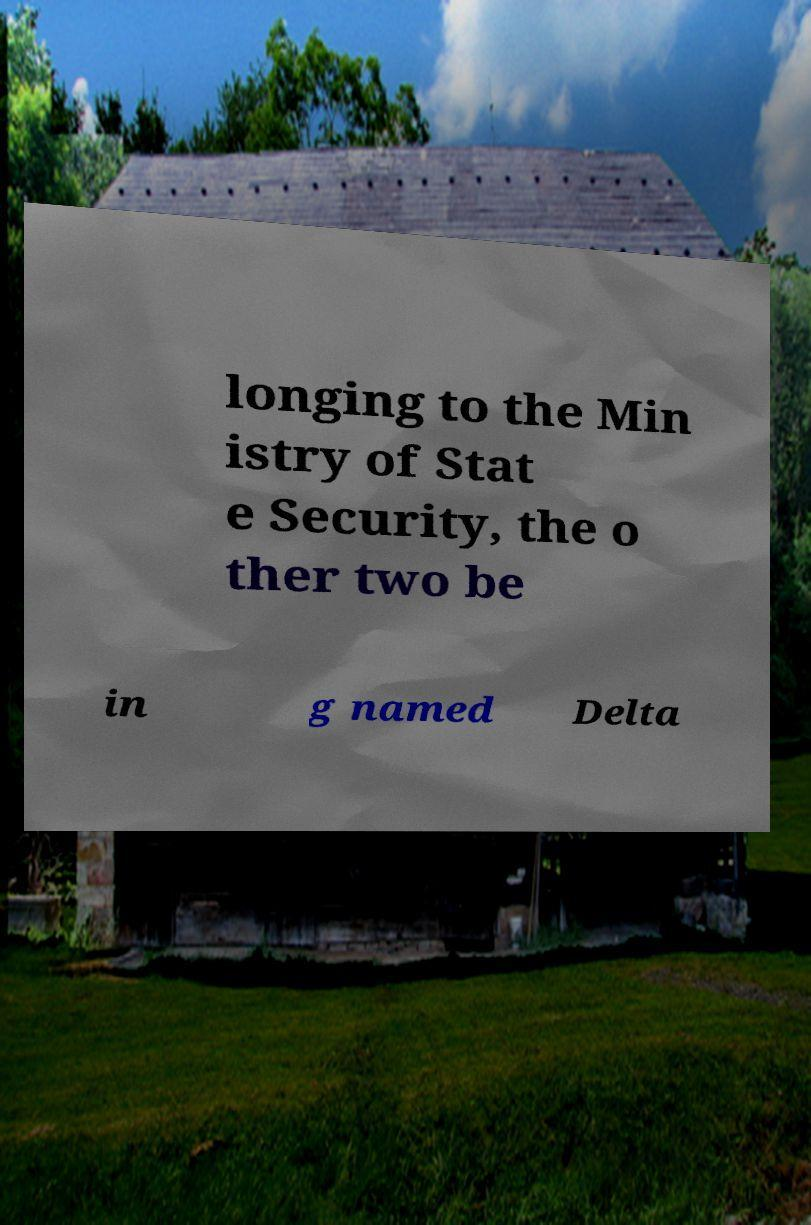Can you read and provide the text displayed in the image?This photo seems to have some interesting text. Can you extract and type it out for me? longing to the Min istry of Stat e Security, the o ther two be in g named Delta 